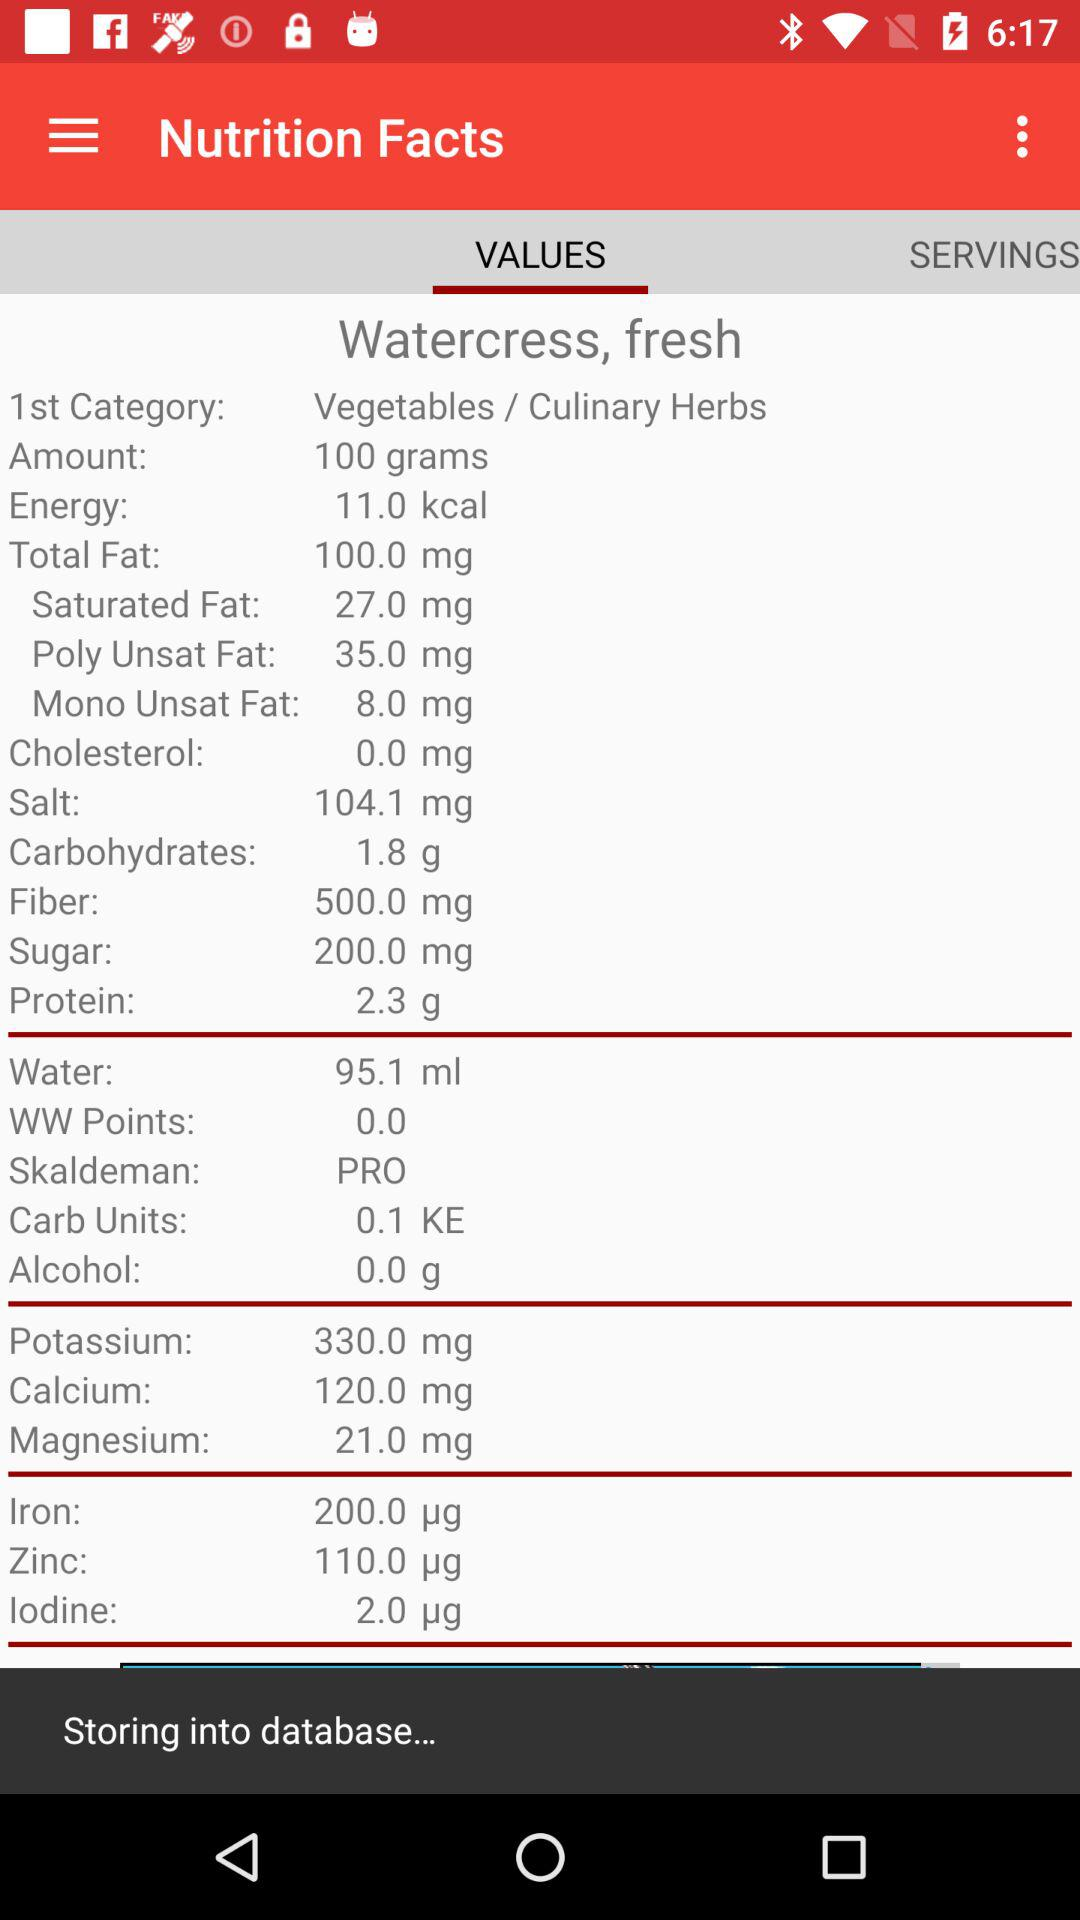Which items are in the 1st category? The items in the 1st category are "Vegetables" and "Culinary Herbs". 